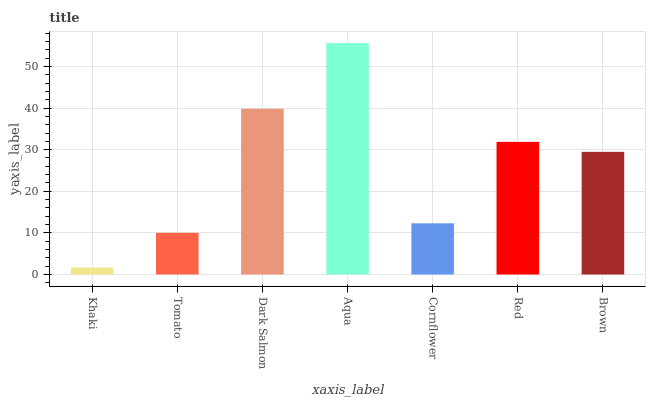Is Khaki the minimum?
Answer yes or no. Yes. Is Aqua the maximum?
Answer yes or no. Yes. Is Tomato the minimum?
Answer yes or no. No. Is Tomato the maximum?
Answer yes or no. No. Is Tomato greater than Khaki?
Answer yes or no. Yes. Is Khaki less than Tomato?
Answer yes or no. Yes. Is Khaki greater than Tomato?
Answer yes or no. No. Is Tomato less than Khaki?
Answer yes or no. No. Is Brown the high median?
Answer yes or no. Yes. Is Brown the low median?
Answer yes or no. Yes. Is Dark Salmon the high median?
Answer yes or no. No. Is Tomato the low median?
Answer yes or no. No. 